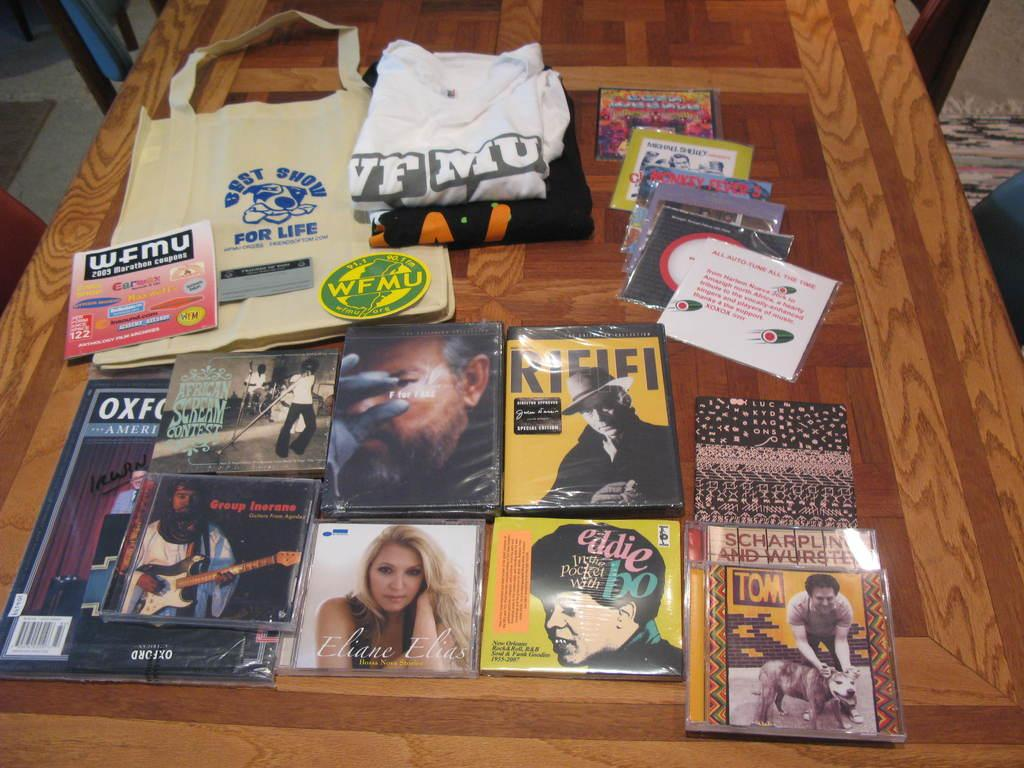What types of items can be seen in the image? There are CD packs, t-shirts, a bag, and a book in the image. Can you describe the other objects in the image? There are other objects in the image, but their specific details are not mentioned in the provided facts. Where is the chair located in the image? The chair is on the right side of the image. What is the chair's proximity to the wall? The chair is near a wall. What type of flooring is visible on the left side of the image? There is a carpet on the floor on the left side of the image. How many cacti are present on the chair in the image? There are no cacti present in the image, as the provided facts do not mention any plants or cacti. 